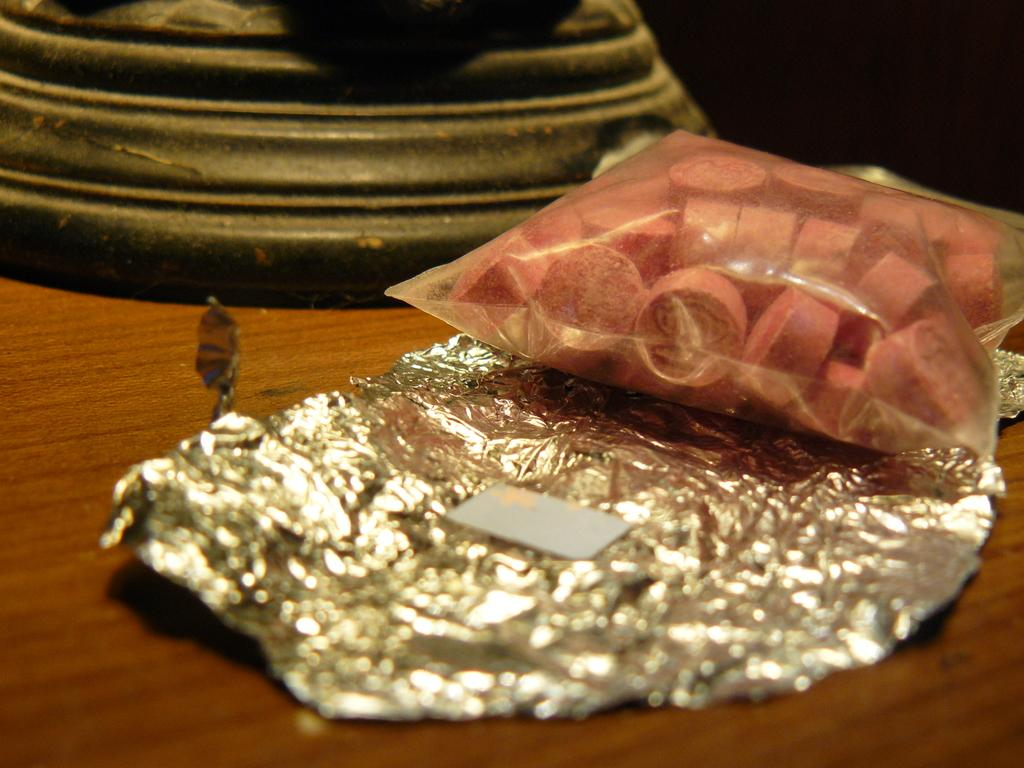What material is present in the image? There is aluminium foil in the image. What is covered by the aluminium foil? There are objects in the cover. What can be seen behind the aluminium foil? There is a background in the image, which contains objects. What is the color of the surface in the image? The surface in the image is brown in color. Reasoning: Let' Let's think step by step in order to produce the conversation. We start by identifying the main material in the image, which is aluminium foil. Then, we describe what the foil is covering and what can be seen behind it. Finally, we mention the color of the surface in the image. Each question is designed to elicit a specific detail about the image that is known from the provided facts. Absurd Question/Answer: How many iron balls are visible in the image? There are no iron balls present in the image. What achievements has the achiever in the image accomplished? There is no achiever or any mention of achievements in the image. 